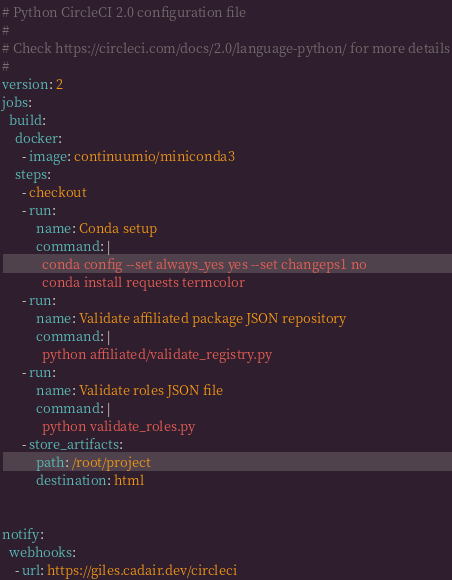Convert code to text. <code><loc_0><loc_0><loc_500><loc_500><_YAML_># Python CircleCI 2.0 configuration file
#
# Check https://circleci.com/docs/2.0/language-python/ for more details
#
version: 2
jobs:
  build:
    docker:
      - image: continuumio/miniconda3
    steps:
      - checkout
      - run:
          name: Conda setup
          command: |
            conda config --set always_yes yes --set changeps1 no
            conda install requests termcolor
      - run:
          name: Validate affiliated package JSON repository
          command: |
            python affiliated/validate_registry.py
      - run:
          name: Validate roles JSON file
          command: |
            python validate_roles.py
      - store_artifacts:
          path: /root/project
          destination: html


notify:
  webhooks:
    - url: https://giles.cadair.dev/circleci
</code> 